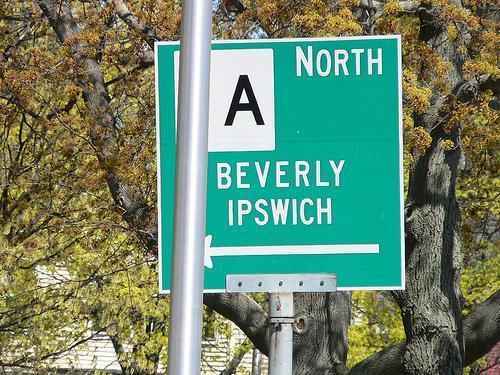How many sings are visible?
Give a very brief answer. 1. 